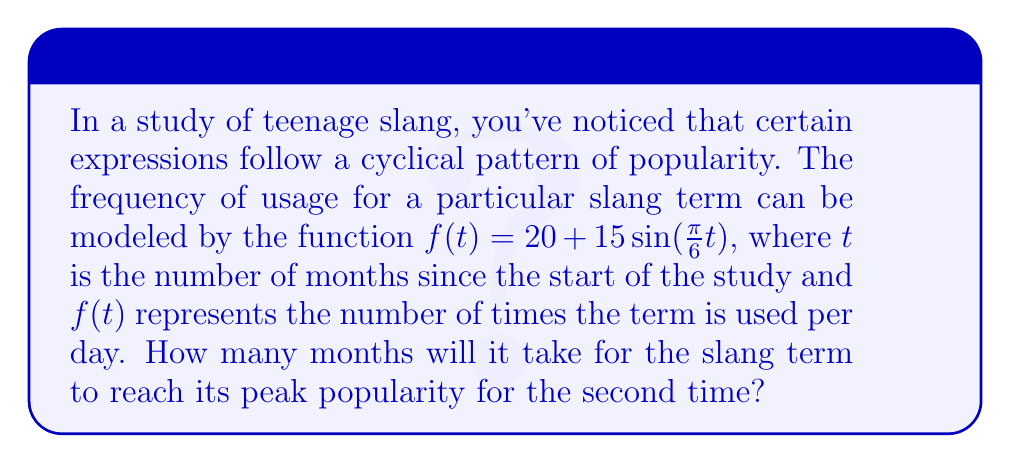What is the answer to this math problem? To solve this problem, we need to follow these steps:

1) First, let's understand what the function represents:
   $f(t) = 20 + 15\sin(\frac{\pi}{6}t)$
   - 20 is the average usage
   - 15 is the amplitude (how much the usage varies from the average)
   - $\frac{\pi}{6}$ is the frequency of the cycle

2) The period of a sine function is given by $\frac{2\pi}{b}$, where $b$ is the coefficient of $t$ inside the sine function.
   In this case, $b = \frac{\pi}{6}$

3) So, the period is:
   $$\frac{2\pi}{\frac{\pi}{6}} = 2\pi \cdot \frac{6}{\pi} = 12$$

4) This means the slang term completes one full cycle every 12 months.

5) The peak popularity occurs at the maximum point of the sine wave. The first peak will be at $t = 3$ (as $\sin(\frac{\pi}{2}) = 1$).

6) The second peak will occur after one full period has passed since the first peak.
   So, $3 + 12 = 15$ months.

Therefore, the slang term will reach its peak popularity for the second time after 15 months.
Answer: 15 months 